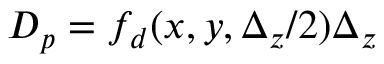Convert formula to latex. <formula><loc_0><loc_0><loc_500><loc_500>D _ { p } = f _ { d } ( x , y , \Delta _ { z } / 2 ) \Delta _ { z }</formula> 